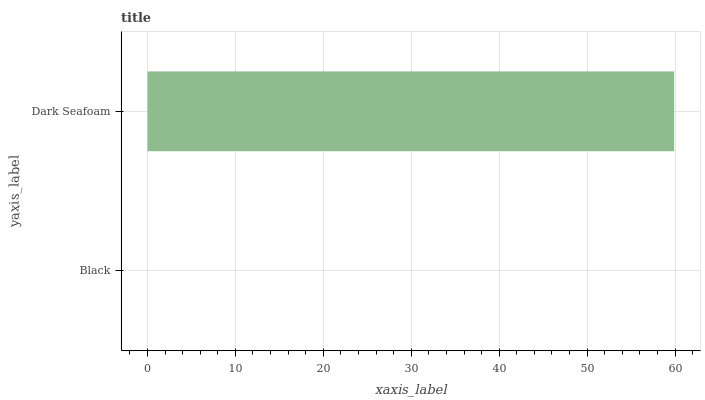Is Black the minimum?
Answer yes or no. Yes. Is Dark Seafoam the maximum?
Answer yes or no. Yes. Is Dark Seafoam the minimum?
Answer yes or no. No. Is Dark Seafoam greater than Black?
Answer yes or no. Yes. Is Black less than Dark Seafoam?
Answer yes or no. Yes. Is Black greater than Dark Seafoam?
Answer yes or no. No. Is Dark Seafoam less than Black?
Answer yes or no. No. Is Dark Seafoam the high median?
Answer yes or no. Yes. Is Black the low median?
Answer yes or no. Yes. Is Black the high median?
Answer yes or no. No. Is Dark Seafoam the low median?
Answer yes or no. No. 